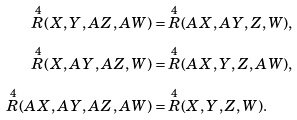Convert formula to latex. <formula><loc_0><loc_0><loc_500><loc_500>\overset { 4 } { R } ( X , Y , A Z , A W ) & = \overset { 4 } { R } ( A X , A Y , Z , W ) , \\ \overset { 4 } { R } ( X , A Y , A Z , W ) & = \overset { 4 } { R } ( A X , Y , Z , A W ) , \\ \overset { 4 } { R } ( A X , A Y , A Z , A W ) & = \overset { 4 } { R } ( X , Y , Z , W ) .</formula> 